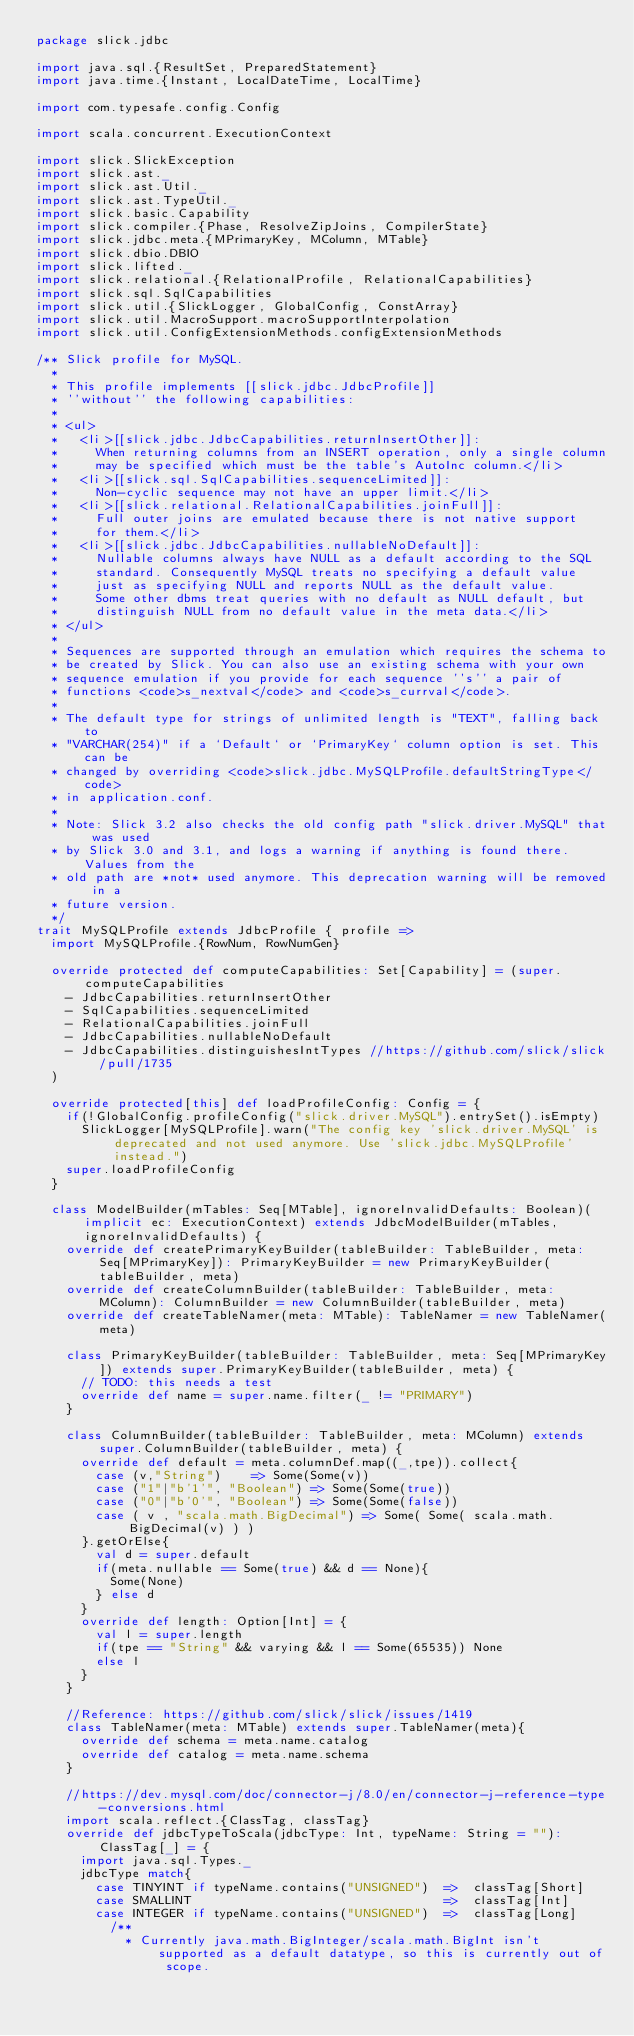Convert code to text. <code><loc_0><loc_0><loc_500><loc_500><_Scala_>package slick.jdbc

import java.sql.{ResultSet, PreparedStatement}
import java.time.{Instant, LocalDateTime, LocalTime}

import com.typesafe.config.Config

import scala.concurrent.ExecutionContext

import slick.SlickException
import slick.ast._
import slick.ast.Util._
import slick.ast.TypeUtil._
import slick.basic.Capability
import slick.compiler.{Phase, ResolveZipJoins, CompilerState}
import slick.jdbc.meta.{MPrimaryKey, MColumn, MTable}
import slick.dbio.DBIO
import slick.lifted._
import slick.relational.{RelationalProfile, RelationalCapabilities}
import slick.sql.SqlCapabilities
import slick.util.{SlickLogger, GlobalConfig, ConstArray}
import slick.util.MacroSupport.macroSupportInterpolation
import slick.util.ConfigExtensionMethods.configExtensionMethods

/** Slick profile for MySQL.
  *
  * This profile implements [[slick.jdbc.JdbcProfile]]
  * ''without'' the following capabilities:
  *
  * <ul>
  *   <li>[[slick.jdbc.JdbcCapabilities.returnInsertOther]]:
  *     When returning columns from an INSERT operation, only a single column
  *     may be specified which must be the table's AutoInc column.</li>
  *   <li>[[slick.sql.SqlCapabilities.sequenceLimited]]:
  *     Non-cyclic sequence may not have an upper limit.</li>
  *   <li>[[slick.relational.RelationalCapabilities.joinFull]]:
  *     Full outer joins are emulated because there is not native support
  *     for them.</li>
  *   <li>[[slick.jdbc.JdbcCapabilities.nullableNoDefault]]:
  *     Nullable columns always have NULL as a default according to the SQL
  *     standard. Consequently MySQL treats no specifying a default value
  *     just as specifying NULL and reports NULL as the default value.
  *     Some other dbms treat queries with no default as NULL default, but
  *     distinguish NULL from no default value in the meta data.</li>
  * </ul>
  *
  * Sequences are supported through an emulation which requires the schema to
  * be created by Slick. You can also use an existing schema with your own
  * sequence emulation if you provide for each sequence ''s'' a pair of
  * functions <code>s_nextval</code> and <code>s_currval</code>.
  *
  * The default type for strings of unlimited length is "TEXT", falling back to
  * "VARCHAR(254)" if a `Default` or `PrimaryKey` column option is set. This can be
  * changed by overriding <code>slick.jdbc.MySQLProfile.defaultStringType</code>
  * in application.conf.
  *
  * Note: Slick 3.2 also checks the old config path "slick.driver.MySQL" that was used
  * by Slick 3.0 and 3.1, and logs a warning if anything is found there. Values from the
  * old path are *not* used anymore. This deprecation warning will be removed in a
  * future version.
  */
trait MySQLProfile extends JdbcProfile { profile =>
  import MySQLProfile.{RowNum, RowNumGen}

  override protected def computeCapabilities: Set[Capability] = (super.computeCapabilities
    - JdbcCapabilities.returnInsertOther
    - SqlCapabilities.sequenceLimited
    - RelationalCapabilities.joinFull
    - JdbcCapabilities.nullableNoDefault
    - JdbcCapabilities.distinguishesIntTypes //https://github.com/slick/slick/pull/1735
  )

  override protected[this] def loadProfileConfig: Config = {
    if(!GlobalConfig.profileConfig("slick.driver.MySQL").entrySet().isEmpty)
      SlickLogger[MySQLProfile].warn("The config key 'slick.driver.MySQL' is deprecated and not used anymore. Use 'slick.jdbc.MySQLProfile' instead.")
    super.loadProfileConfig
  }

  class ModelBuilder(mTables: Seq[MTable], ignoreInvalidDefaults: Boolean)(implicit ec: ExecutionContext) extends JdbcModelBuilder(mTables, ignoreInvalidDefaults) {
    override def createPrimaryKeyBuilder(tableBuilder: TableBuilder, meta: Seq[MPrimaryKey]): PrimaryKeyBuilder = new PrimaryKeyBuilder(tableBuilder, meta)
    override def createColumnBuilder(tableBuilder: TableBuilder, meta: MColumn): ColumnBuilder = new ColumnBuilder(tableBuilder, meta)
    override def createTableNamer(meta: MTable): TableNamer = new TableNamer(meta)

    class PrimaryKeyBuilder(tableBuilder: TableBuilder, meta: Seq[MPrimaryKey]) extends super.PrimaryKeyBuilder(tableBuilder, meta) {
      // TODO: this needs a test
      override def name = super.name.filter(_ != "PRIMARY")
    }

    class ColumnBuilder(tableBuilder: TableBuilder, meta: MColumn) extends super.ColumnBuilder(tableBuilder, meta) {
      override def default = meta.columnDef.map((_,tpe)).collect{
        case (v,"String")    => Some(Some(v))
        case ("1"|"b'1'", "Boolean") => Some(Some(true))
        case ("0"|"b'0'", "Boolean") => Some(Some(false))
        case ( v , "scala.math.BigDecimal") => Some( Some( scala.math.BigDecimal(v) ) )
      }.getOrElse{
        val d = super.default
        if(meta.nullable == Some(true) && d == None){
          Some(None)
        } else d
      }
      override def length: Option[Int] = {
        val l = super.length
        if(tpe == "String" && varying && l == Some(65535)) None
        else l
      }
    }

    //Reference: https://github.com/slick/slick/issues/1419
    class TableNamer(meta: MTable) extends super.TableNamer(meta){
      override def schema = meta.name.catalog
      override def catalog = meta.name.schema 
    }

    //https://dev.mysql.com/doc/connector-j/8.0/en/connector-j-reference-type-conversions.html
    import scala.reflect.{ClassTag, classTag}
    override def jdbcTypeToScala(jdbcType: Int, typeName: String = ""): ClassTag[_] = {
      import java.sql.Types._
      jdbcType match{
        case TINYINT if typeName.contains("UNSIGNED")  =>  classTag[Short]
        case SMALLINT                                  =>  classTag[Int]
        case INTEGER if typeName.contains("UNSIGNED")  =>  classTag[Long]
          /**
            * Currently java.math.BigInteger/scala.math.BigInt isn't supported as a default datatype, so this is currently out of scope.</code> 